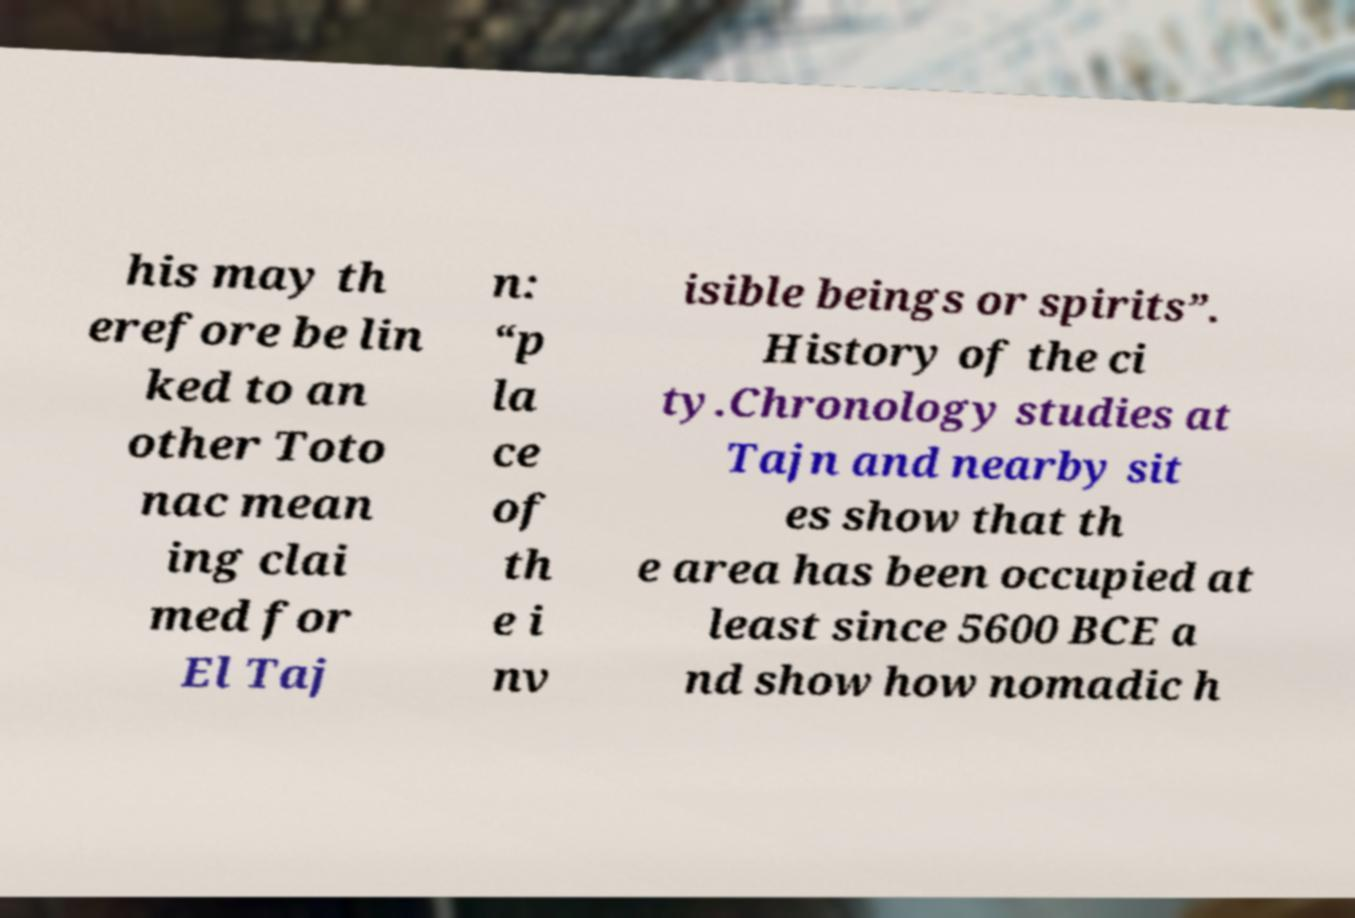Can you accurately transcribe the text from the provided image for me? his may th erefore be lin ked to an other Toto nac mean ing clai med for El Taj n: “p la ce of th e i nv isible beings or spirits”. History of the ci ty.Chronology studies at Tajn and nearby sit es show that th e area has been occupied at least since 5600 BCE a nd show how nomadic h 